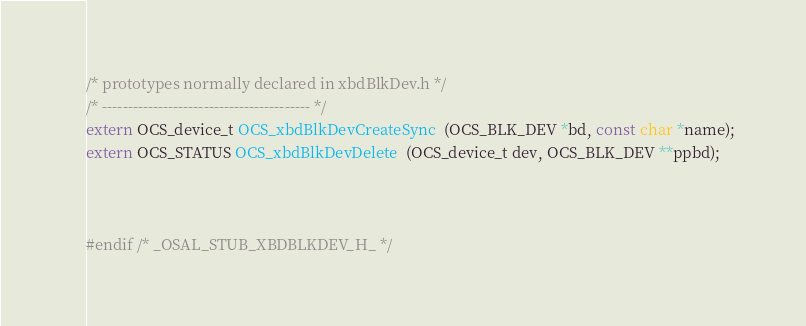Convert code to text. <code><loc_0><loc_0><loc_500><loc_500><_C_>/* prototypes normally declared in xbdBlkDev.h */
/* ----------------------------------------- */
extern OCS_device_t OCS_xbdBlkDevCreateSync  (OCS_BLK_DEV *bd, const char *name);
extern OCS_STATUS OCS_xbdBlkDevDelete  (OCS_device_t dev, OCS_BLK_DEV **ppbd);



#endif /* _OSAL_STUB_XBDBLKDEV_H_ */

</code> 